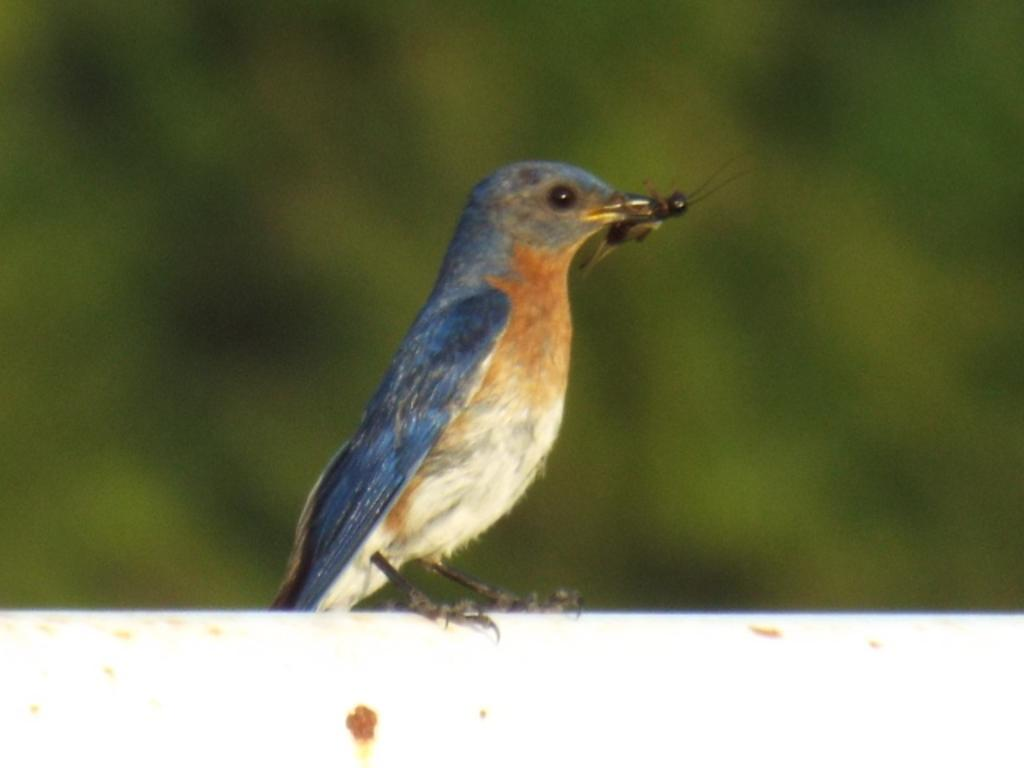What type of animal can be seen in the image? There is a bird in the image. What is the bird doing in the image? The bird is holding an insect in its mouth. Can you describe the background of the image? The background of the image is blurred. What type of cattle can be seen grazing in the background of the image? There is no cattle present in the image; it features a bird holding an insect in its mouth with a blurred background. What type of quartz can be seen in the bird's beak in the image? There is no quartz present in the image; the bird is holding an insect in its mouth. 